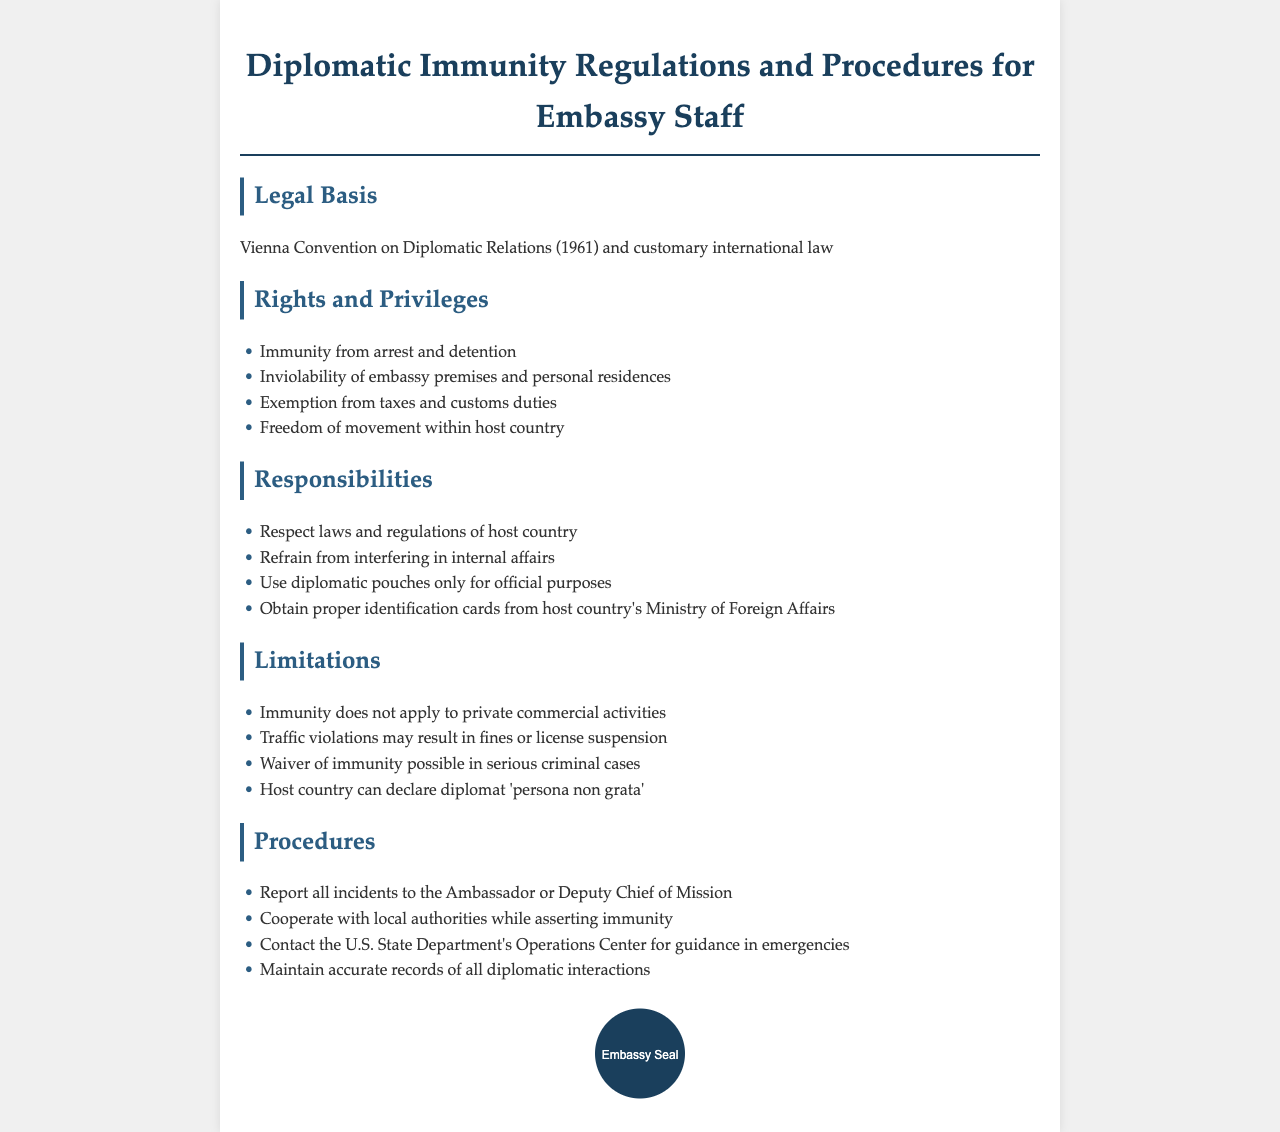What is the legal basis for diplomatic immunity? The legal basis is mentioned in the document as the Vienna Convention on Diplomatic Relations (1961) and customary international law.
Answer: Vienna Convention on Diplomatic Relations (1961) What is one right of embassy staff? The document lists several rights, one of which is immunity from arrest and detention.
Answer: Immunity from arrest and detention What must embassy staff refrain from? The responsibilities section indicates that embassy staff must refrain from interfering in internal affairs.
Answer: Interfering in internal affairs What is one limitation of diplomatic immunity? The limitations section notes that immunity does not apply to private commercial activities.
Answer: Private commercial activities Who should incidents be reported to? The procedures section specifies that all incidents should be reported to the Ambassador or Deputy Chief of Mission.
Answer: Ambassador or Deputy Chief of Mission 